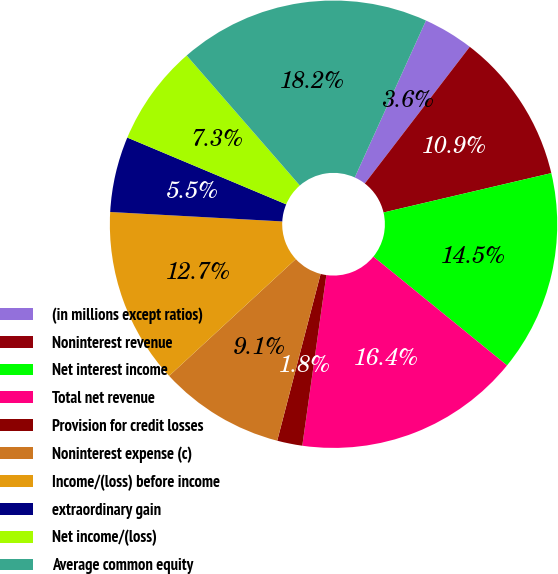Convert chart. <chart><loc_0><loc_0><loc_500><loc_500><pie_chart><fcel>(in millions except ratios)<fcel>Noninterest revenue<fcel>Net interest income<fcel>Total net revenue<fcel>Provision for credit losses<fcel>Noninterest expense (c)<fcel>Income/(loss) before income<fcel>extraordinary gain<fcel>Net income/(loss)<fcel>Average common equity<nl><fcel>3.64%<fcel>10.91%<fcel>14.54%<fcel>16.36%<fcel>1.82%<fcel>9.09%<fcel>12.73%<fcel>5.46%<fcel>7.27%<fcel>18.18%<nl></chart> 